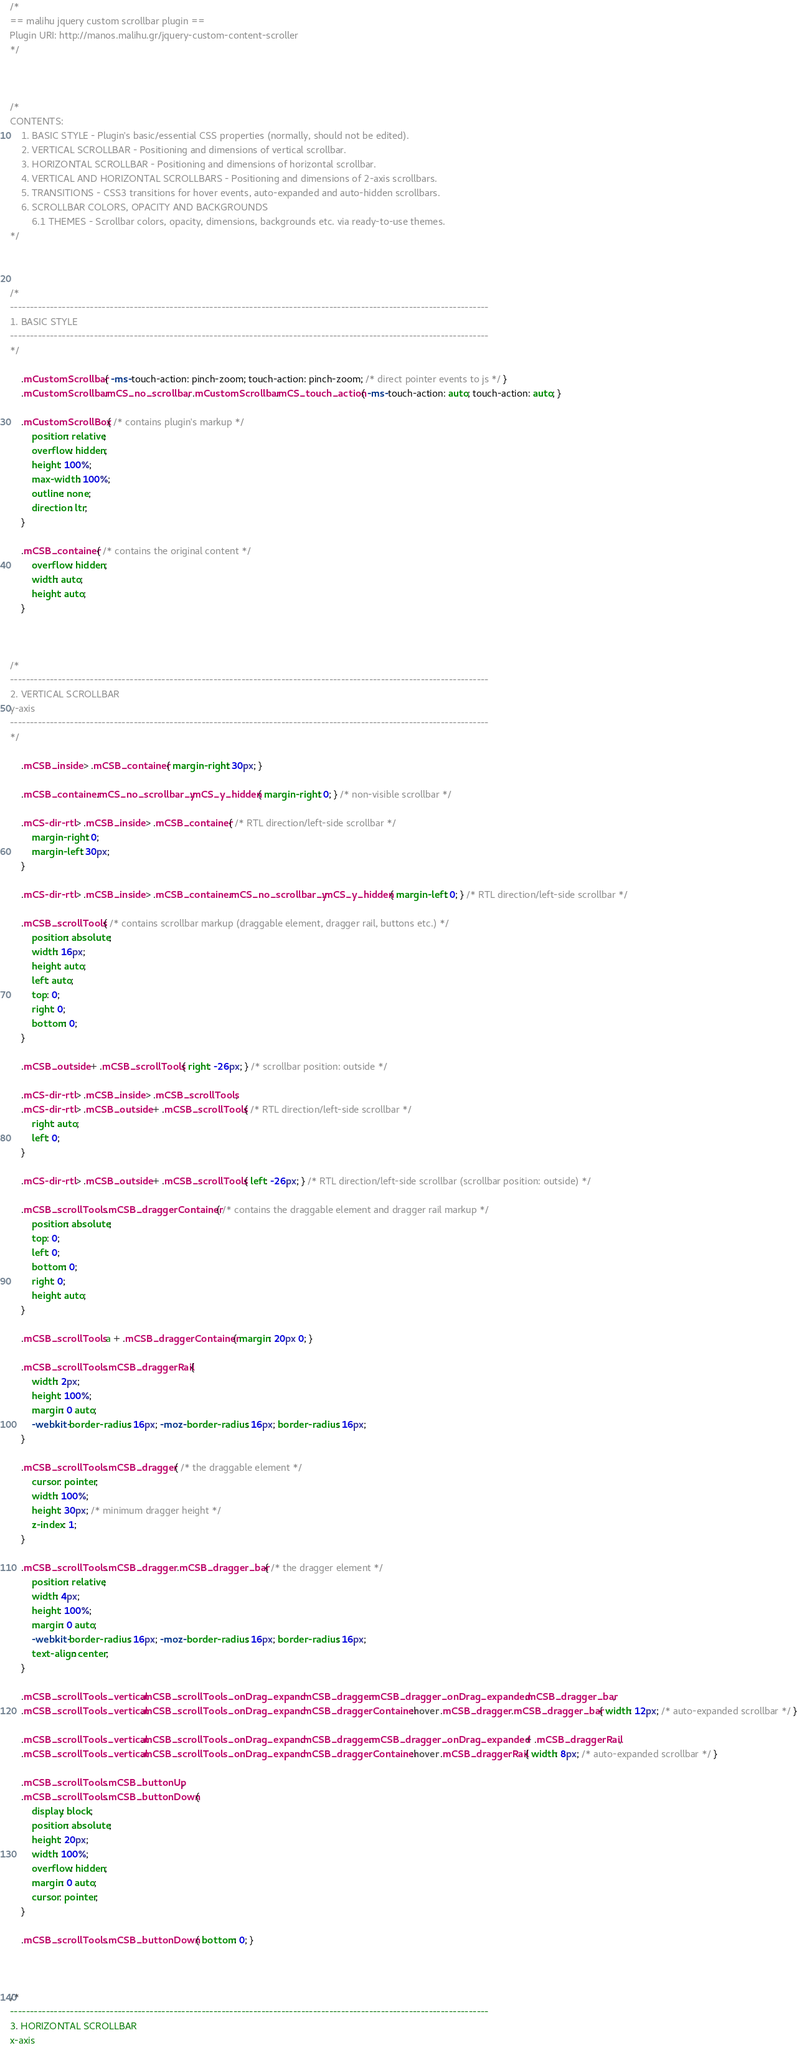<code> <loc_0><loc_0><loc_500><loc_500><_CSS_>/*
== malihu jquery custom scrollbar plugin ==
Plugin URI: http://manos.malihu.gr/jquery-custom-content-scroller
*/



/*
CONTENTS: 
	1. BASIC STYLE - Plugin's basic/essential CSS properties (normally, should not be edited). 
	2. VERTICAL SCROLLBAR - Positioning and dimensions of vertical scrollbar. 
	3. HORIZONTAL SCROLLBAR - Positioning and dimensions of horizontal scrollbar.
	4. VERTICAL AND HORIZONTAL SCROLLBARS - Positioning and dimensions of 2-axis scrollbars. 
	5. TRANSITIONS - CSS3 transitions for hover events, auto-expanded and auto-hidden scrollbars. 
	6. SCROLLBAR COLORS, OPACITY AND BACKGROUNDS 
		6.1 THEMES - Scrollbar colors, opacity, dimensions, backgrounds etc. via ready-to-use themes.
*/



/* 
------------------------------------------------------------------------------------------------------------------------
1. BASIC STYLE  
------------------------------------------------------------------------------------------------------------------------
*/

	.mCustomScrollbar{ -ms-touch-action: pinch-zoom; touch-action: pinch-zoom; /* direct pointer events to js */ }
	.mCustomScrollbar.mCS_no_scrollbar, .mCustomScrollbar.mCS_touch_action{ -ms-touch-action: auto; touch-action: auto; }
	
	.mCustomScrollBox{ /* contains plugin's markup */
		position: relative;
		overflow: hidden;
		height: 100%;
		max-width: 100%;
		outline: none;
		direction: ltr;
	}

	.mCSB_container{ /* contains the original content */
		overflow: hidden;
		width: auto;
		height: auto;
	}



/* 
------------------------------------------------------------------------------------------------------------------------
2. VERTICAL SCROLLBAR 
y-axis
------------------------------------------------------------------------------------------------------------------------
*/

	.mCSB_inside > .mCSB_container{ margin-right: 30px; }

	.mCSB_container.mCS_no_scrollbar_y.mCS_y_hidden{ margin-right: 0; } /* non-visible scrollbar */
	
	.mCS-dir-rtl > .mCSB_inside > .mCSB_container{ /* RTL direction/left-side scrollbar */
		margin-right: 0;
		margin-left: 30px;
	}
	
	.mCS-dir-rtl > .mCSB_inside > .mCSB_container.mCS_no_scrollbar_y.mCS_y_hidden{ margin-left: 0; } /* RTL direction/left-side scrollbar */

	.mCSB_scrollTools{ /* contains scrollbar markup (draggable element, dragger rail, buttons etc.) */
		position: absolute;
		width: 16px;
		height: auto;
		left: auto;
		top: 0;
		right: 0;
		bottom: 0;
	}

	.mCSB_outside + .mCSB_scrollTools{ right: -26px; } /* scrollbar position: outside */
	
	.mCS-dir-rtl > .mCSB_inside > .mCSB_scrollTools, 
	.mCS-dir-rtl > .mCSB_outside + .mCSB_scrollTools{ /* RTL direction/left-side scrollbar */
		right: auto;
		left: 0;
	}
	
	.mCS-dir-rtl > .mCSB_outside + .mCSB_scrollTools{ left: -26px; } /* RTL direction/left-side scrollbar (scrollbar position: outside) */

	.mCSB_scrollTools .mCSB_draggerContainer{ /* contains the draggable element and dragger rail markup */
		position: absolute;
		top: 0;
		left: 0;
		bottom: 0;
		right: 0; 
		height: auto;
	}

	.mCSB_scrollTools a + .mCSB_draggerContainer{ margin: 20px 0; }

	.mCSB_scrollTools .mCSB_draggerRail{
		width: 2px;
		height: 100%;
		margin: 0 auto;
		-webkit-border-radius: 16px; -moz-border-radius: 16px; border-radius: 16px;
	}

	.mCSB_scrollTools .mCSB_dragger{ /* the draggable element */
		cursor: pointer;
		width: 100%;
		height: 30px; /* minimum dragger height */
		z-index: 1;
	}

	.mCSB_scrollTools .mCSB_dragger .mCSB_dragger_bar{ /* the dragger element */
		position: relative;
		width: 4px;
		height: 100%;
		margin: 0 auto;
		-webkit-border-radius: 16px; -moz-border-radius: 16px; border-radius: 16px;
		text-align: center;
	}
	
	.mCSB_scrollTools_vertical.mCSB_scrollTools_onDrag_expand .mCSB_dragger.mCSB_dragger_onDrag_expanded .mCSB_dragger_bar, 
	.mCSB_scrollTools_vertical.mCSB_scrollTools_onDrag_expand .mCSB_draggerContainer:hover .mCSB_dragger .mCSB_dragger_bar{ width: 12px; /* auto-expanded scrollbar */ }
	
	.mCSB_scrollTools_vertical.mCSB_scrollTools_onDrag_expand .mCSB_dragger.mCSB_dragger_onDrag_expanded + .mCSB_draggerRail, 
	.mCSB_scrollTools_vertical.mCSB_scrollTools_onDrag_expand .mCSB_draggerContainer:hover .mCSB_draggerRail{ width: 8px; /* auto-expanded scrollbar */ }

	.mCSB_scrollTools .mCSB_buttonUp,
	.mCSB_scrollTools .mCSB_buttonDown{
		display: block;
		position: absolute;
		height: 20px;
		width: 100%;
		overflow: hidden;
		margin: 0 auto;
		cursor: pointer;
	}

	.mCSB_scrollTools .mCSB_buttonDown{ bottom: 0; }



/* 
------------------------------------------------------------------------------------------------------------------------
3. HORIZONTAL SCROLLBAR 
x-axis</code> 